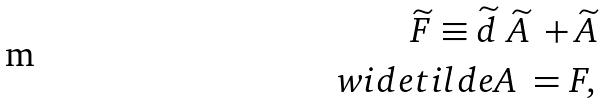<formula> <loc_0><loc_0><loc_500><loc_500>\widetilde { F } \equiv \widetilde { d } \ \widetilde { A } \ + \widetilde { A } \\ w i d e t i l d e { A } \ = F ,</formula> 